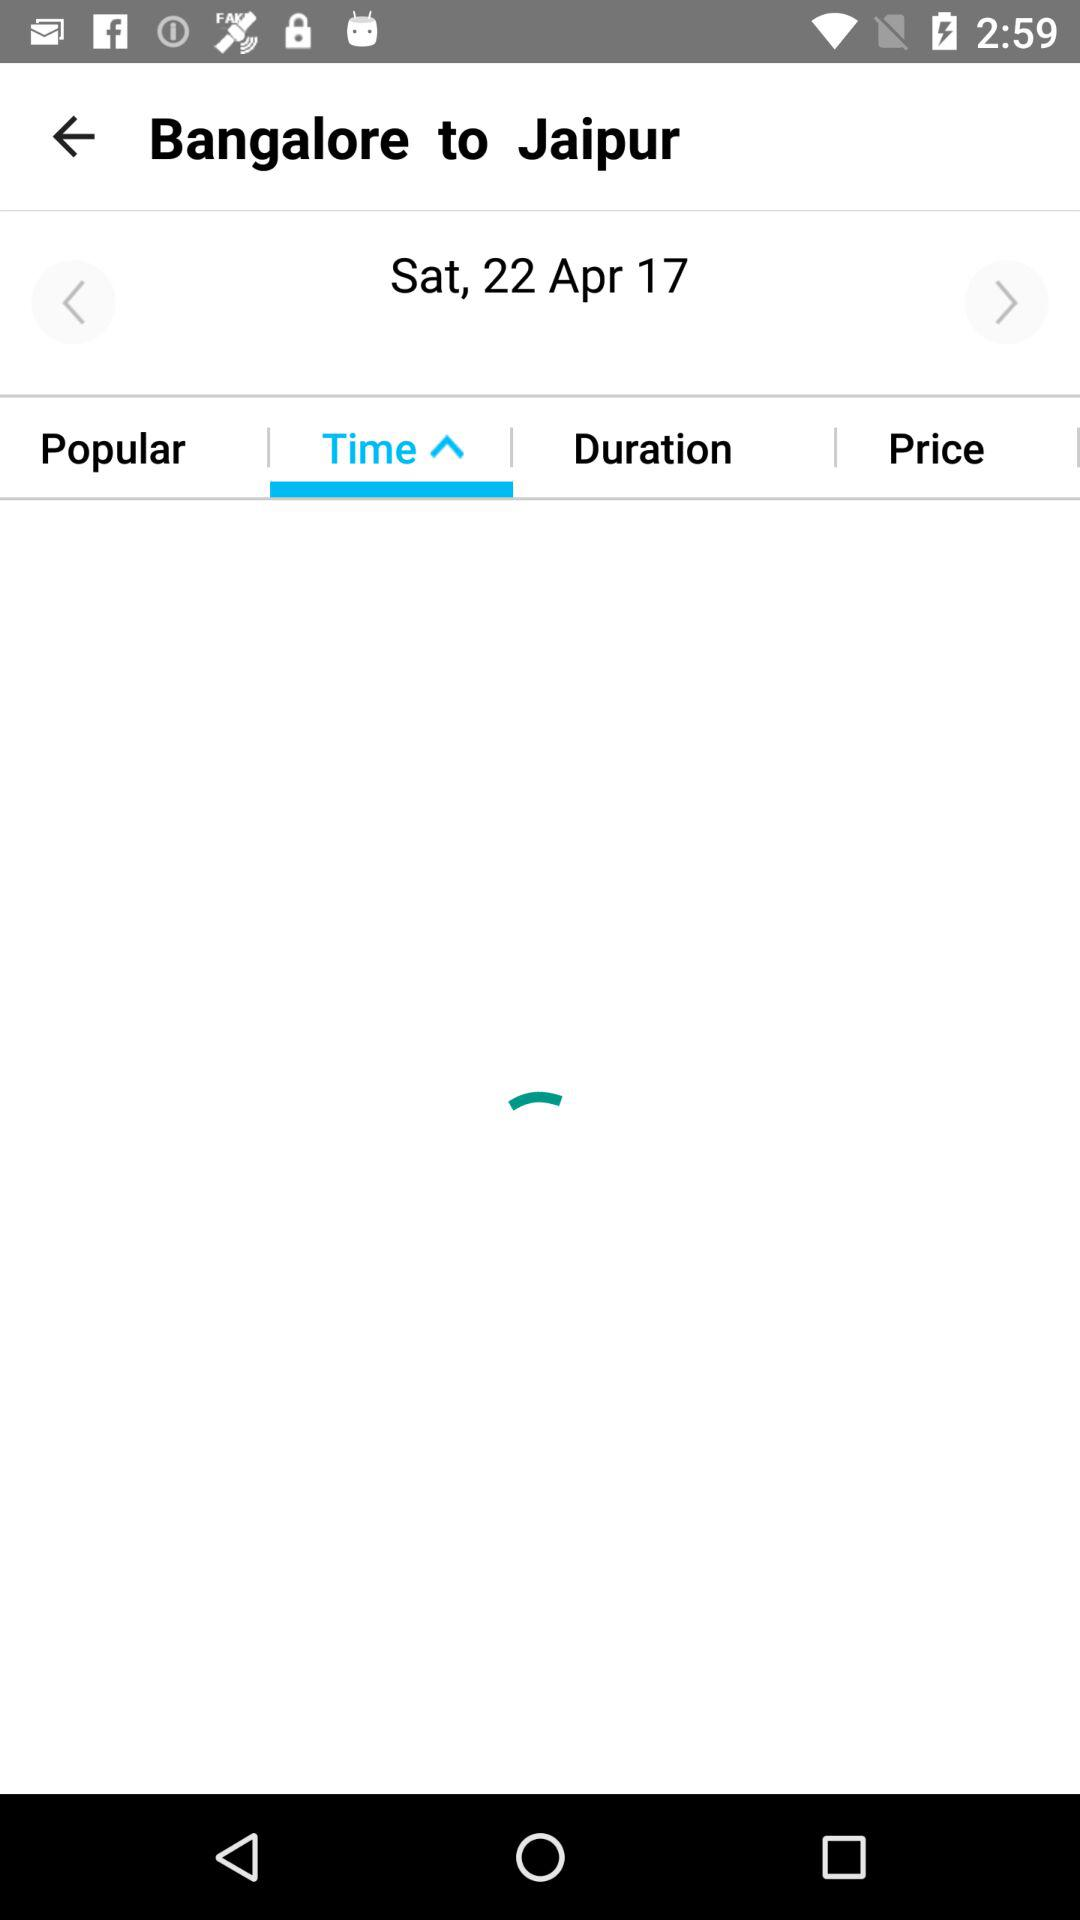How much does the trip cost?
When the provided information is insufficient, respond with <no answer>. <no answer> 